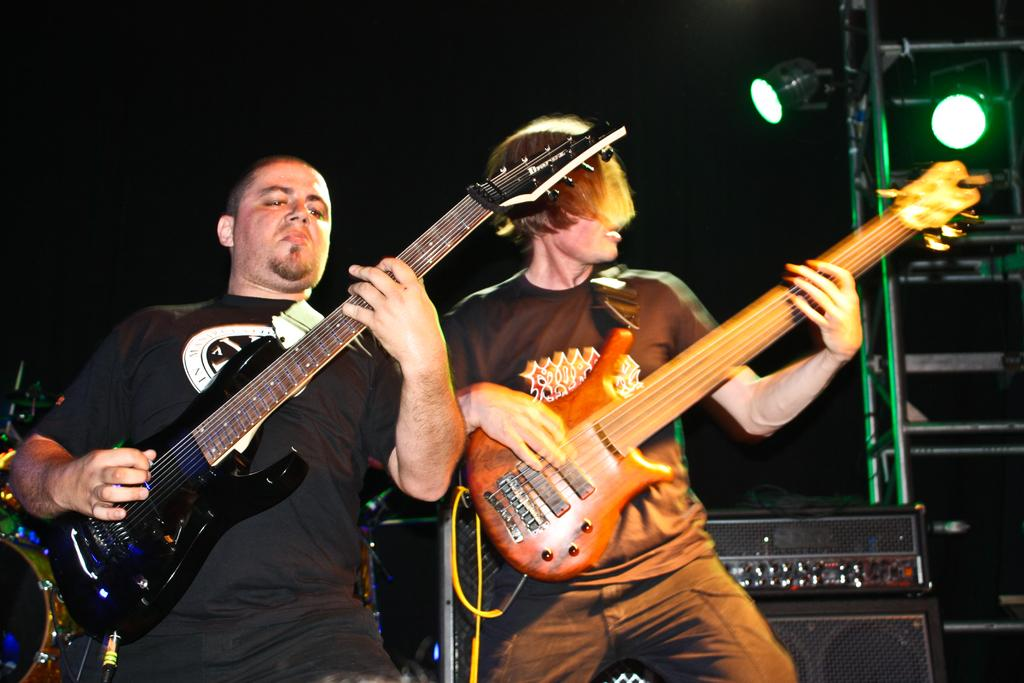How many people are in the image? There are two men in the image. What are the men doing in the image? The men are standing and holding guitars in their hands. What can be seen in the background of the image? There are two lights and speakers in the background of the image. What type of dinosaurs can be seen in the image? There are no dinosaurs present in the image. What is being exchanged between the two men in the image? There is no exchange happening between the two men in the image; they are simply standing with their guitars. 